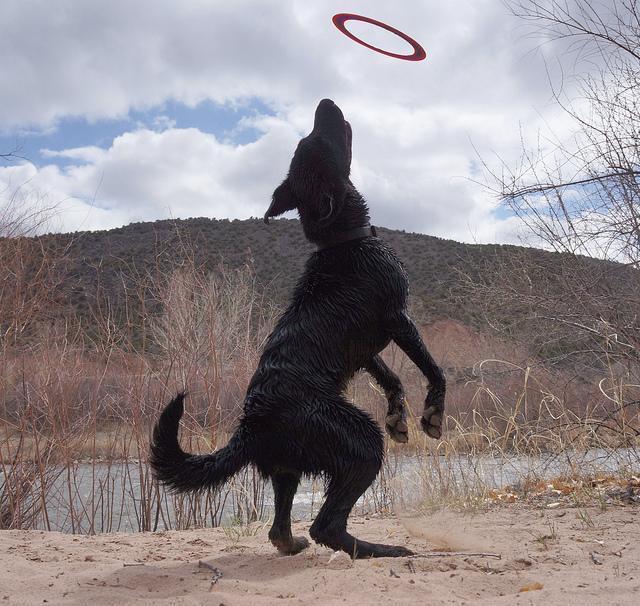How many frisbees are in the picture?
Give a very brief answer. 1. 